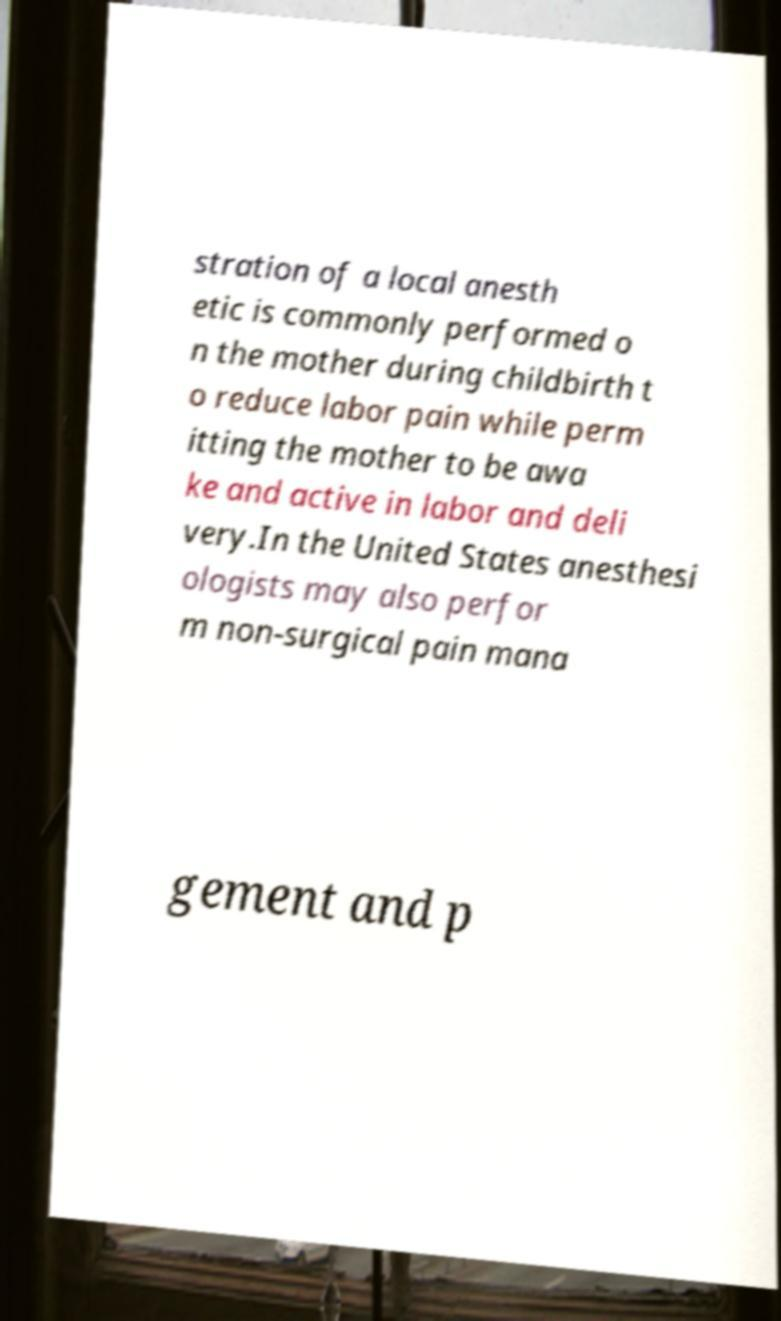Can you read and provide the text displayed in the image?This photo seems to have some interesting text. Can you extract and type it out for me? stration of a local anesth etic is commonly performed o n the mother during childbirth t o reduce labor pain while perm itting the mother to be awa ke and active in labor and deli very.In the United States anesthesi ologists may also perfor m non-surgical pain mana gement and p 